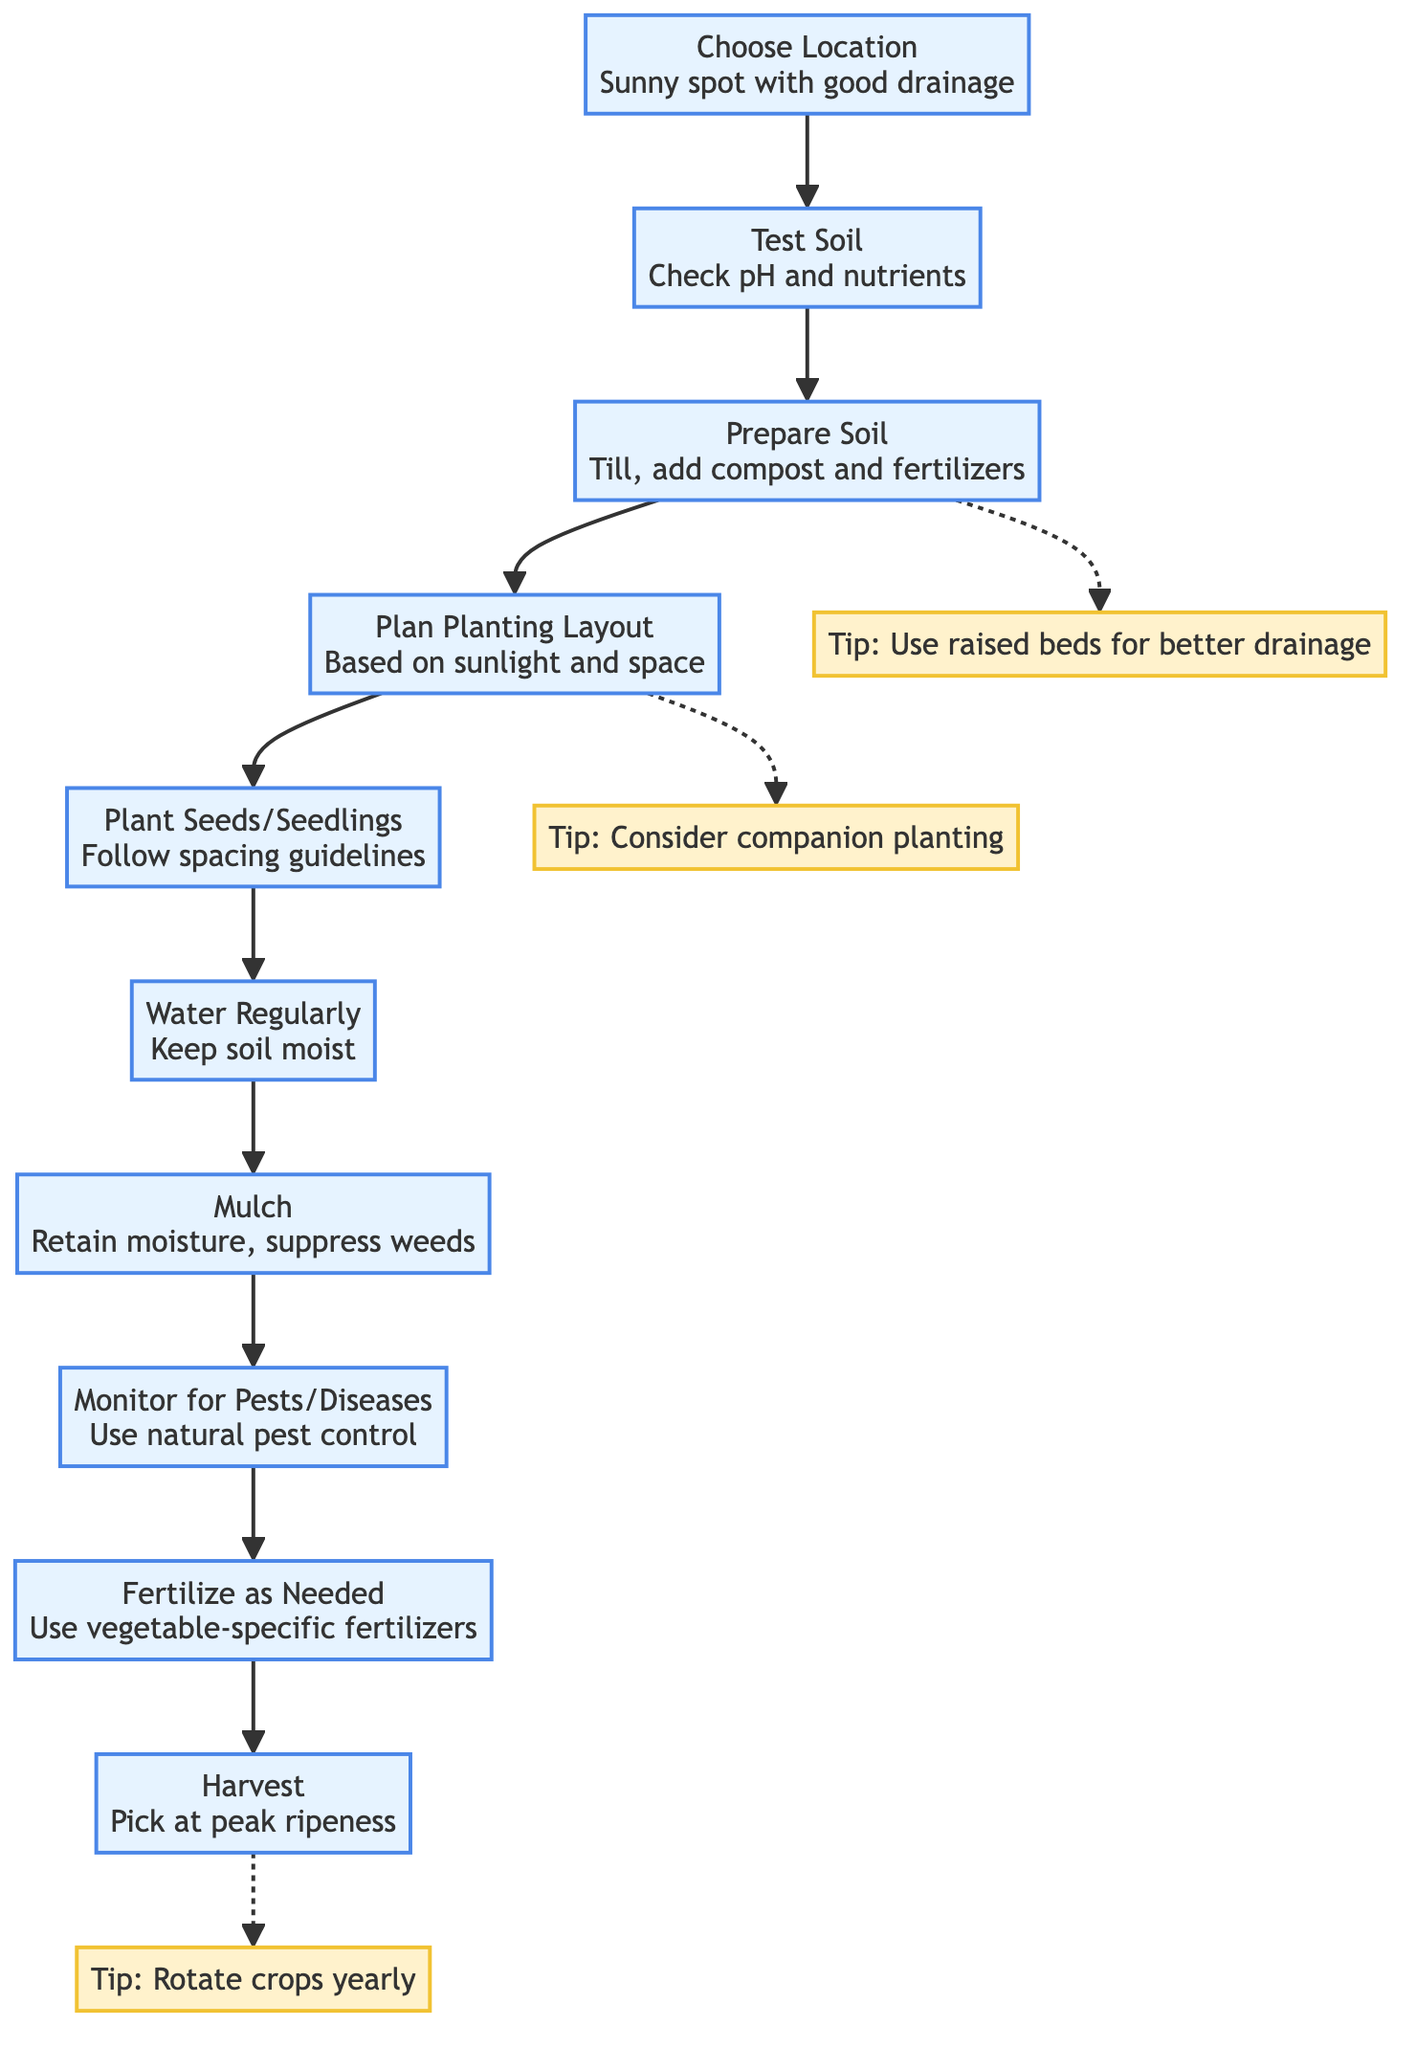What is the first step in preparing a vegetable garden? The diagram indicates that the first step is to choose a location, specifically a sunny spot with good drainage.
Answer: Choose Location How many steps are outlined for preparing a vegetable garden? By counting the nodes in the flowchart, there are a total of ten steps outlined, from choosing a location to harvesting.
Answer: 10 What is suggested to do after planting seeds or seedlings? According to the diagram, the next step after planting seeds or seedlings is to water regularly, keeping the soil moist.
Answer: Water Regularly What is recommended to use for enhancing soil quality before planting? The diagram advises to prepare the soil by tilling it and adding compost and fertilizers.
Answer: Prepare Soil Which step involves monitoring for pests or diseases? The diagram shows that monitoring for pests and diseases is the eighth step in the sequence of preparing a vegetable garden.
Answer: Monitor for Pests/Diseases What tip is associated with planning the planting layout? The diagram provides a tip related to companion planting, indicating that it is a good practice to consider.
Answer: Consider companion planting What step comes after mulching? After mulching, the next step indicated in the diagram is to monitor for pests and diseases.
Answer: Monitor for Pests/Diseases What is the final step in the vegetable garden preparation process? The last step outlined in the diagram is harvesting, where vegetables should be picked at peak ripeness.
Answer: Harvest Which step suggests using raised beds for improved drainage? The diagram suggests using raised beds for better drainage as a tip, connected to the soil preparation step.
Answer: Use raised beds for better drainage 